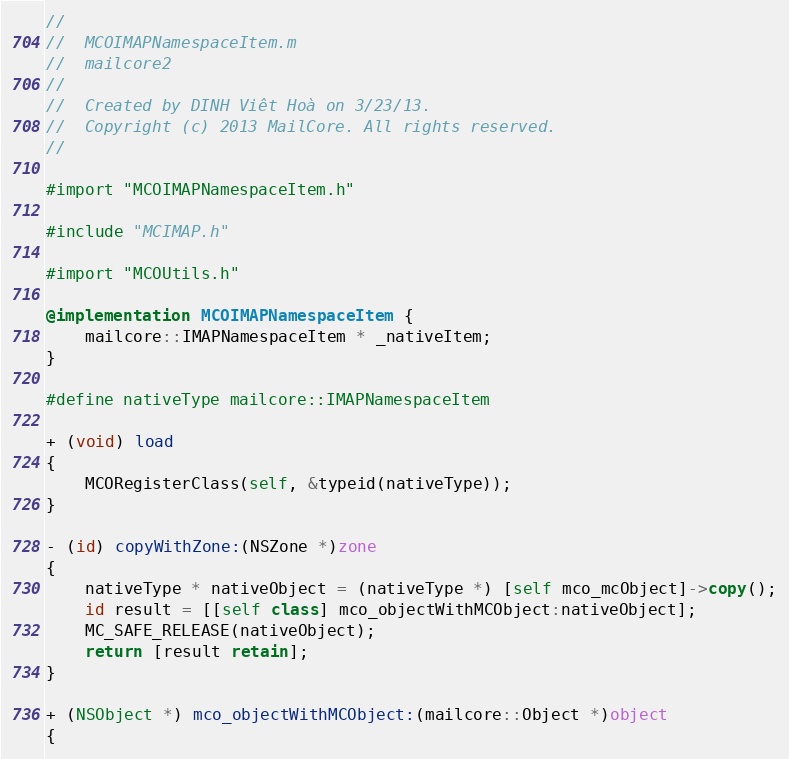Convert code to text. <code><loc_0><loc_0><loc_500><loc_500><_ObjectiveC_>//
//  MCOIMAPNamespaceItem.m
//  mailcore2
//
//  Created by DINH Viêt Hoà on 3/23/13.
//  Copyright (c) 2013 MailCore. All rights reserved.
//

#import "MCOIMAPNamespaceItem.h"

#include "MCIMAP.h"

#import "MCOUtils.h"

@implementation MCOIMAPNamespaceItem {
    mailcore::IMAPNamespaceItem * _nativeItem;
}

#define nativeType mailcore::IMAPNamespaceItem

+ (void) load
{
    MCORegisterClass(self, &typeid(nativeType));
}

- (id) copyWithZone:(NSZone *)zone
{
    nativeType * nativeObject = (nativeType *) [self mco_mcObject]->copy();
    id result = [[self class] mco_objectWithMCObject:nativeObject];
    MC_SAFE_RELEASE(nativeObject);
    return [result retain];
}

+ (NSObject *) mco_objectWithMCObject:(mailcore::Object *)object
{</code> 